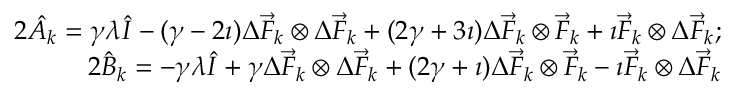Convert formula to latex. <formula><loc_0><loc_0><loc_500><loc_500>\begin{array} { r l r } & { 2 \hat { A } _ { k } = \gamma \lambda \hat { I } - ( \gamma - 2 \imath ) \Delta \vec { F } _ { k } \otimes \Delta \vec { F } _ { k } + ( 2 \gamma + 3 \imath ) \Delta \vec { F } _ { k } \otimes \vec { F } _ { k } + \imath \vec { F } _ { k } \otimes \Delta \vec { F } _ { k } ; } \\ & { 2 \hat { B } _ { k } = - \gamma \lambda \hat { I } + \gamma \Delta \vec { F } _ { k } \otimes \Delta \vec { F } _ { k } + ( 2 \gamma + \imath ) \Delta \vec { F } _ { k } \otimes \vec { F } _ { k } - \imath \vec { F } _ { k } \otimes \Delta \vec { F } _ { k } } \end{array}</formula> 